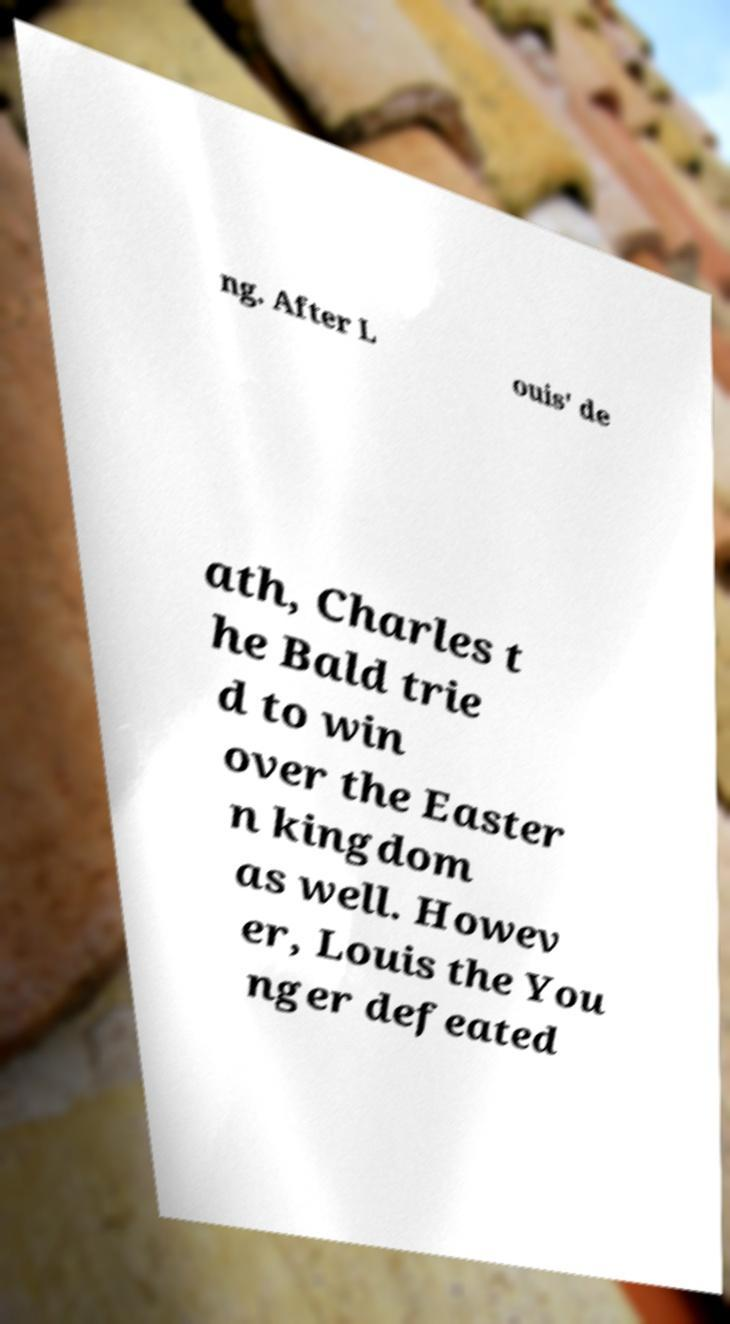There's text embedded in this image that I need extracted. Can you transcribe it verbatim? ng. After L ouis' de ath, Charles t he Bald trie d to win over the Easter n kingdom as well. Howev er, Louis the You nger defeated 